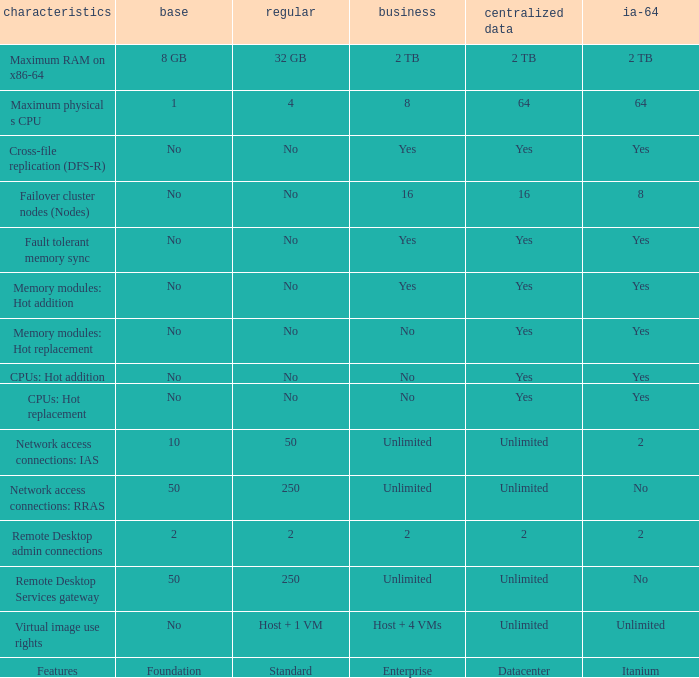Which Features have Yes listed under Datacenter? Cross-file replication (DFS-R), Fault tolerant memory sync, Memory modules: Hot addition, Memory modules: Hot replacement, CPUs: Hot addition, CPUs: Hot replacement. 